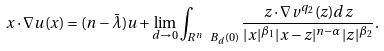Convert formula to latex. <formula><loc_0><loc_0><loc_500><loc_500>x \cdot \nabla u ( x ) = ( n - \bar { \lambda } ) u + \lim _ { d \to 0 } \int _ { R ^ { n } \ B _ { d } ( 0 ) } \frac { z \cdot \nabla v ^ { q _ { 2 } } ( z ) d z } { | x | ^ { \beta _ { 1 } } | x - z | ^ { n - \alpha } | z | ^ { \beta _ { 2 } } } .</formula> 